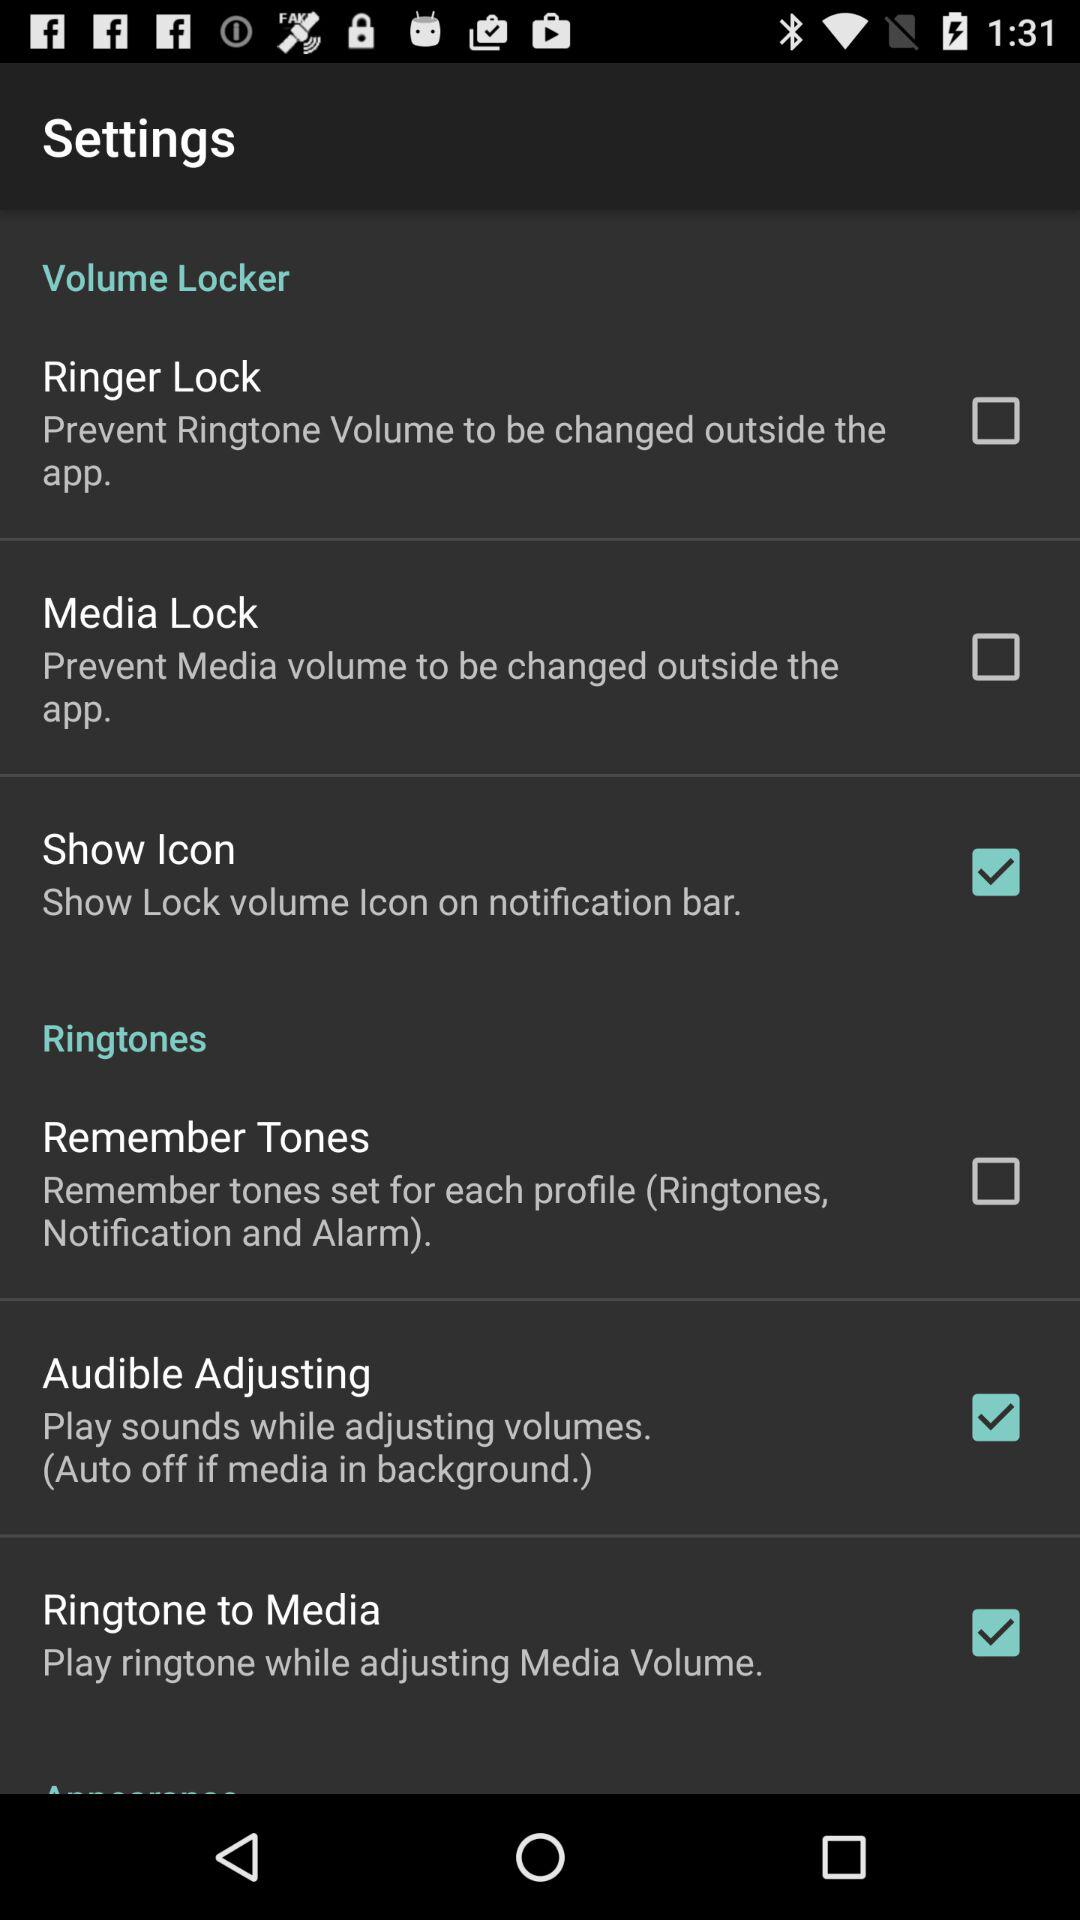What is the status of "Audible Adjusting"? The status is "on". 